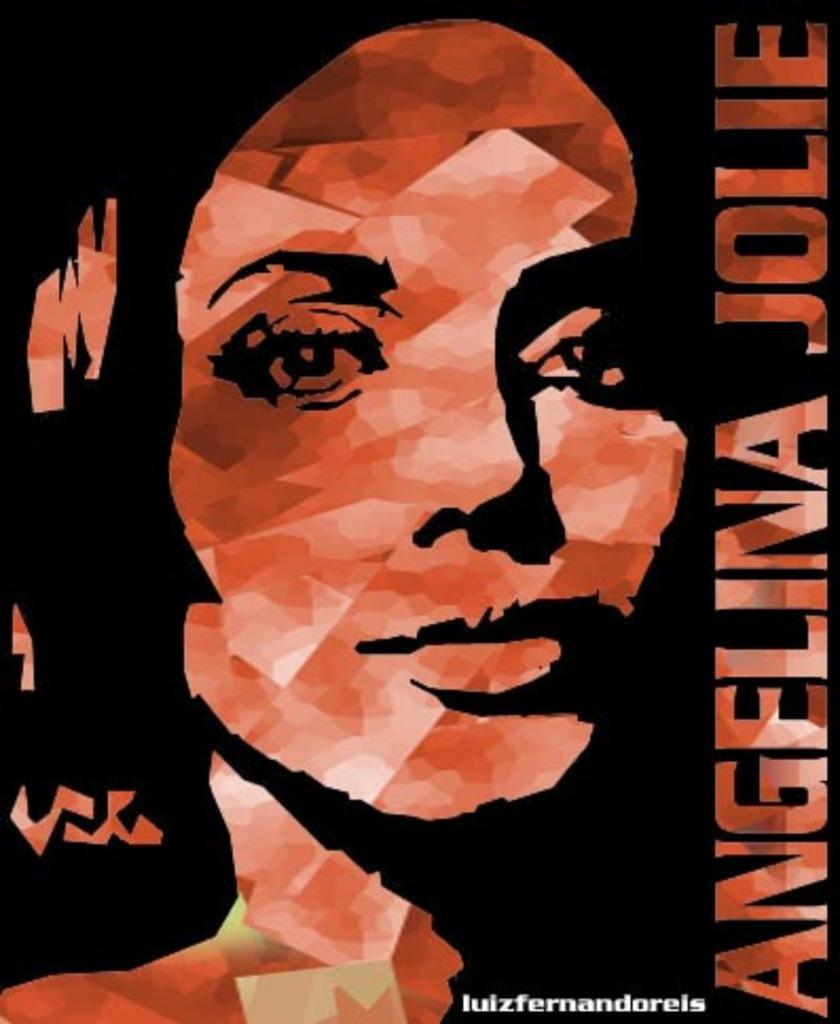What is the main subject of the poster in the image? The poster contains the face of a person. Where is the text located on the poster? There is text on the right side and at the bottom of the poster. What type of twig can be seen growing out of the person's face on the poster? There is no twig present on the person's face in the poster. How does the person on the poster react to the shock of the twig? There is no twig or shock present in the poster, as it only features the person's face and text. 